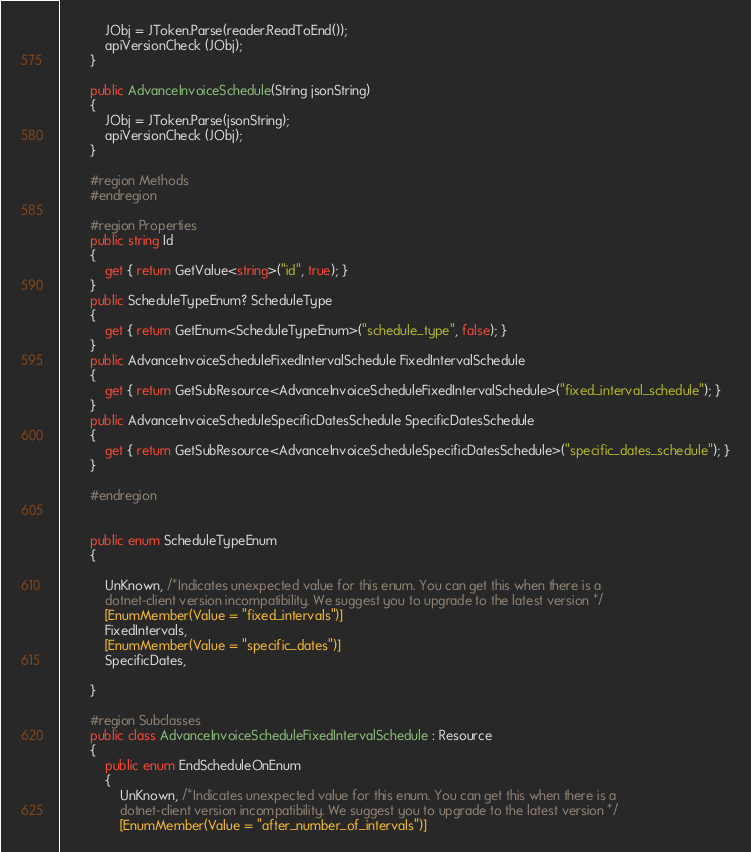<code> <loc_0><loc_0><loc_500><loc_500><_C#_>            JObj = JToken.Parse(reader.ReadToEnd());
            apiVersionCheck (JObj);    
        }

        public AdvanceInvoiceSchedule(String jsonString)
        {
            JObj = JToken.Parse(jsonString);
            apiVersionCheck (JObj);
        }

        #region Methods
        #endregion
        
        #region Properties
        public string Id 
        {
            get { return GetValue<string>("id", true); }
        }
        public ScheduleTypeEnum? ScheduleType 
        {
            get { return GetEnum<ScheduleTypeEnum>("schedule_type", false); }
        }
        public AdvanceInvoiceScheduleFixedIntervalSchedule FixedIntervalSchedule 
        {
            get { return GetSubResource<AdvanceInvoiceScheduleFixedIntervalSchedule>("fixed_interval_schedule"); }
        }
        public AdvanceInvoiceScheduleSpecificDatesSchedule SpecificDatesSchedule 
        {
            get { return GetSubResource<AdvanceInvoiceScheduleSpecificDatesSchedule>("specific_dates_schedule"); }
        }
        
        #endregion
        

        public enum ScheduleTypeEnum
        {

            UnKnown, /*Indicates unexpected value for this enum. You can get this when there is a
            dotnet-client version incompatibility. We suggest you to upgrade to the latest version */
            [EnumMember(Value = "fixed_intervals")]
            FixedIntervals,
            [EnumMember(Value = "specific_dates")]
            SpecificDates,

        }

        #region Subclasses
        public class AdvanceInvoiceScheduleFixedIntervalSchedule : Resource
        {
            public enum EndScheduleOnEnum
            {
                UnKnown, /*Indicates unexpected value for this enum. You can get this when there is a
                dotnet-client version incompatibility. We suggest you to upgrade to the latest version */
                [EnumMember(Value = "after_number_of_intervals")]</code> 